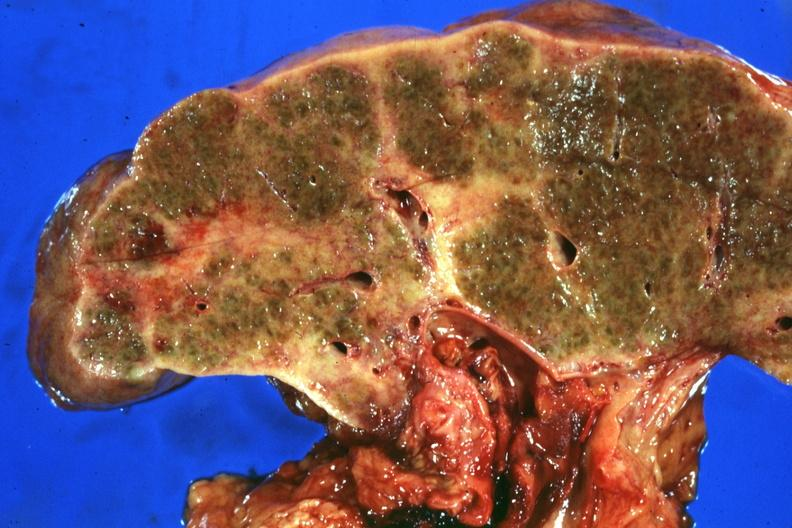what is present?
Answer the question using a single word or phrase. Liver 